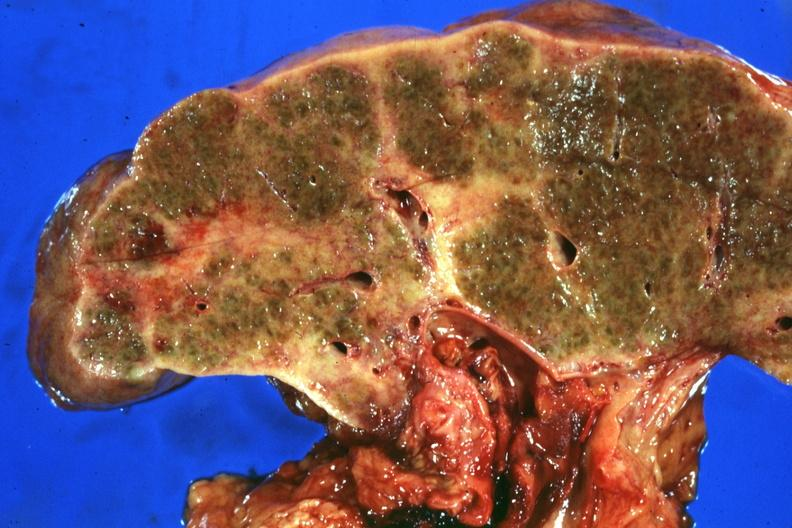what is present?
Answer the question using a single word or phrase. Liver 